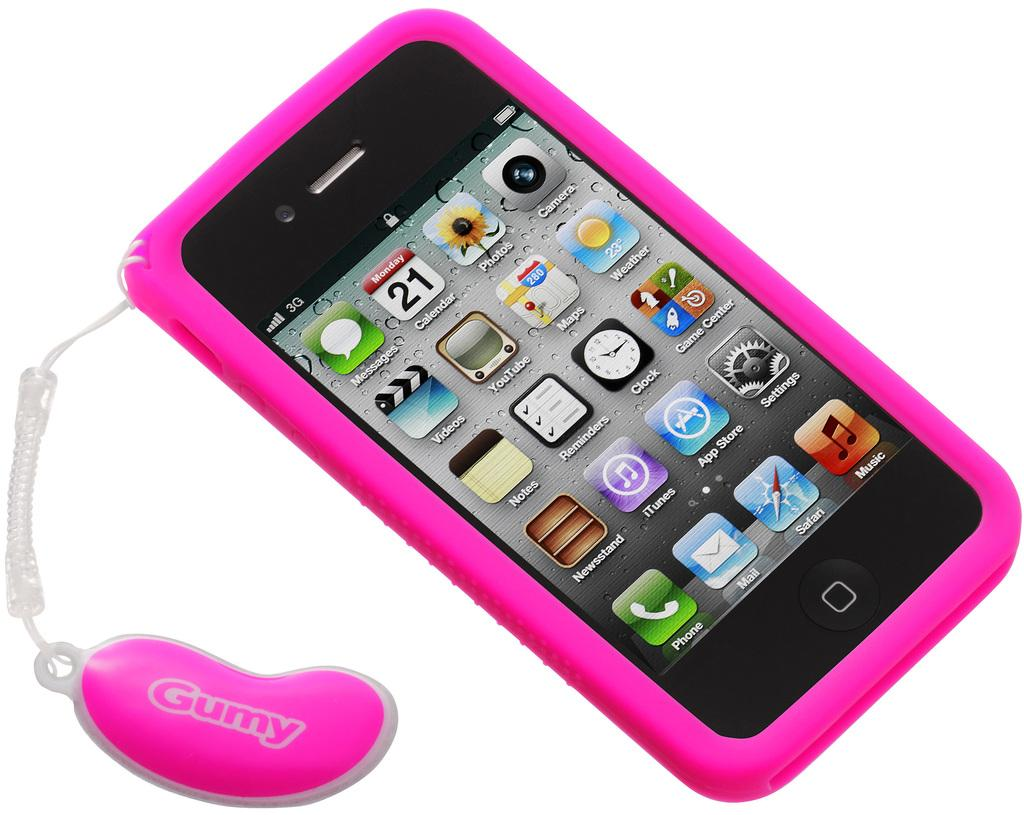<image>
Describe the image concisely. A cell phone has a pink case with a piece to the side that says Gumy.. 